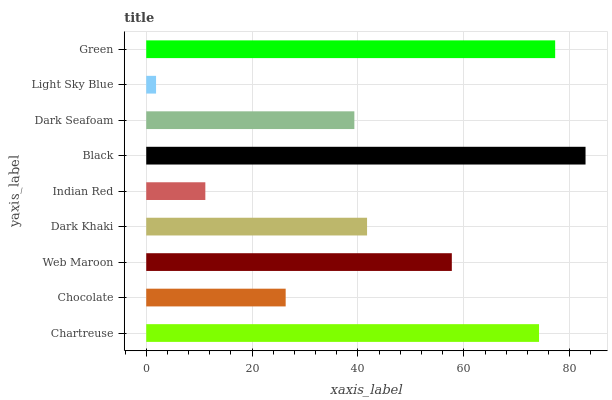Is Light Sky Blue the minimum?
Answer yes or no. Yes. Is Black the maximum?
Answer yes or no. Yes. Is Chocolate the minimum?
Answer yes or no. No. Is Chocolate the maximum?
Answer yes or no. No. Is Chartreuse greater than Chocolate?
Answer yes or no. Yes. Is Chocolate less than Chartreuse?
Answer yes or no. Yes. Is Chocolate greater than Chartreuse?
Answer yes or no. No. Is Chartreuse less than Chocolate?
Answer yes or no. No. Is Dark Khaki the high median?
Answer yes or no. Yes. Is Dark Khaki the low median?
Answer yes or no. Yes. Is Web Maroon the high median?
Answer yes or no. No. Is Indian Red the low median?
Answer yes or no. No. 